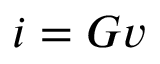<formula> <loc_0><loc_0><loc_500><loc_500>i = G v</formula> 